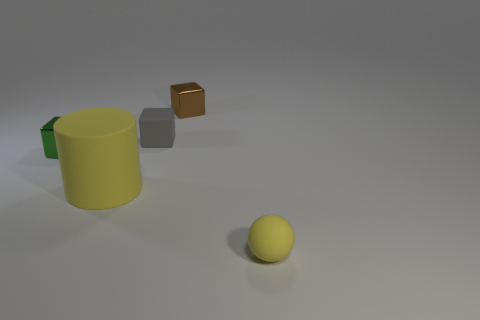Add 4 gray matte cubes. How many objects exist? 9 Subtract all balls. How many objects are left? 4 Subtract 1 yellow cylinders. How many objects are left? 4 Subtract all small blue cubes. Subtract all small gray objects. How many objects are left? 4 Add 4 rubber things. How many rubber things are left? 7 Add 3 small yellow rubber blocks. How many small yellow rubber blocks exist? 3 